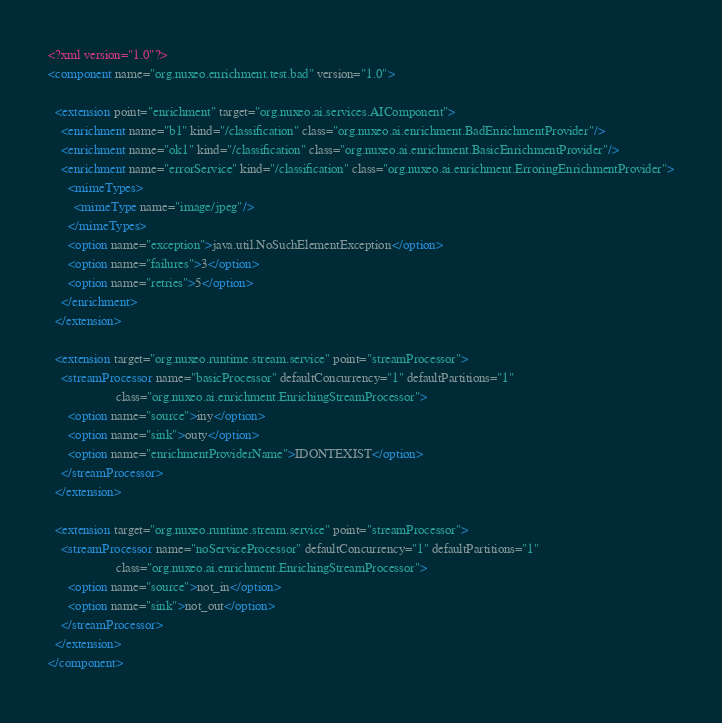<code> <loc_0><loc_0><loc_500><loc_500><_XML_><?xml version="1.0"?>
<component name="org.nuxeo.enrichment.test.bad" version="1.0">

  <extension point="enrichment" target="org.nuxeo.ai.services.AIComponent">
    <enrichment name="b1" kind="/classification" class="org.nuxeo.ai.enrichment.BadEnrichmentProvider"/>
    <enrichment name="ok1" kind="/classification" class="org.nuxeo.ai.enrichment.BasicEnrichmentProvider"/>
    <enrichment name="errorService" kind="/classification" class="org.nuxeo.ai.enrichment.ErroringEnrichmentProvider">
      <mimeTypes>
        <mimeType name="image/jpeg"/>
      </mimeTypes>
      <option name="exception">java.util.NoSuchElementException</option>
      <option name="failures">3</option>
      <option name="retries">5</option>
    </enrichment>
  </extension>

  <extension target="org.nuxeo.runtime.stream.service" point="streamProcessor">
    <streamProcessor name="basicProcessor" defaultConcurrency="1" defaultPartitions="1"
                     class="org.nuxeo.ai.enrichment.EnrichingStreamProcessor">
      <option name="source">iny</option>
      <option name="sink">outy</option>
      <option name="enrichmentProviderName">IDONTEXIST</option>
    </streamProcessor>
  </extension>

  <extension target="org.nuxeo.runtime.stream.service" point="streamProcessor">
    <streamProcessor name="noServiceProcessor" defaultConcurrency="1" defaultPartitions="1"
                     class="org.nuxeo.ai.enrichment.EnrichingStreamProcessor">
      <option name="source">not_in</option>
      <option name="sink">not_out</option>
    </streamProcessor>
  </extension>
</component>
</code> 